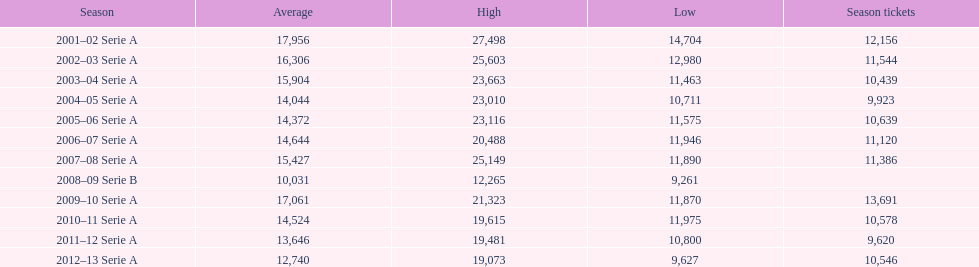In how many seasons at the stadio ennio tardini were there 11,000 or more season ticket holders? 5. 